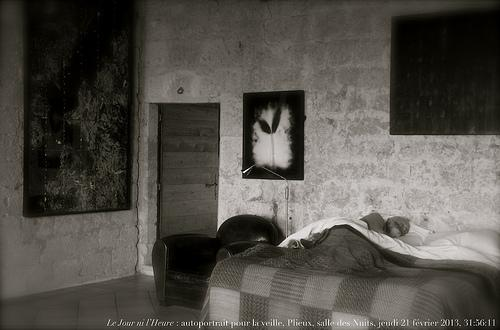Question: what shape is the pattern on the blanket?
Choices:
A. Diamonds.
B. Squares.
C. Checks.
D. Pinstripe.
Answer with the letter. Answer: B Question: what side of the bed is the door on?
Choices:
A. The left.
B. The right.
C. There is no door.
D. There is no bed.
Answer with the letter. Answer: A Question: where is the large crack in the wall?
Choices:
A. By the window.
B. By the door.
C. By the microwave.
D. In the corner.
Answer with the letter. Answer: D 